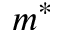<formula> <loc_0><loc_0><loc_500><loc_500>m ^ { * }</formula> 